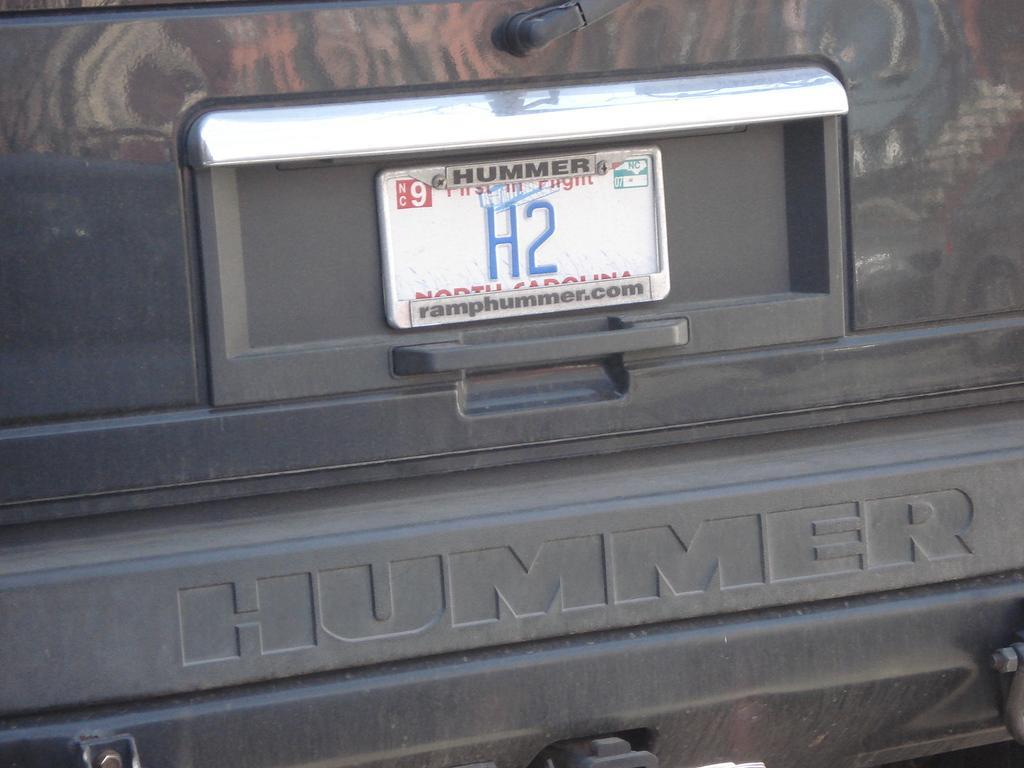How would you summarize this image in a sentence or two? In this picture we can see a number plate and a door handle of a vehicle and some objects. 